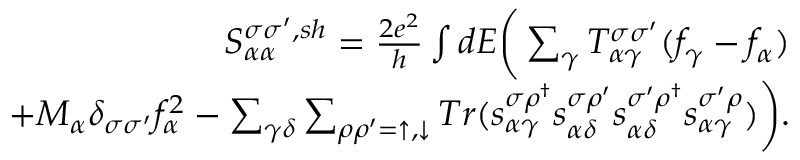Convert formula to latex. <formula><loc_0><loc_0><loc_500><loc_500>\begin{array} { r } { { S _ { \alpha \alpha } ^ { \sigma \sigma ^ { \prime } , s h } } = \frac { 2 e ^ { 2 } } { h } \int d E \left ( \sum _ { \gamma } T _ { \alpha \gamma } ^ { \sigma \sigma ^ { \prime } } ( f _ { \gamma } - f _ { \alpha } ) } \\ { + M _ { \alpha } \delta _ { \sigma \sigma ^ { \prime } } f _ { \alpha } ^ { 2 } - \sum _ { \gamma \delta } \sum _ { \rho \rho ^ { \prime } = \uparrow , \downarrow } T r ( s _ { \alpha \gamma } ^ { \sigma \rho ^ { \dagger } } s _ { \alpha \delta } ^ { \sigma \rho ^ { \prime } } s _ { \alpha \delta } ^ { \sigma ^ { \prime } \rho ^ { \dagger } } s _ { \alpha \gamma } ^ { \sigma ^ { \prime } \rho } ) \right ) . } \end{array}</formula> 